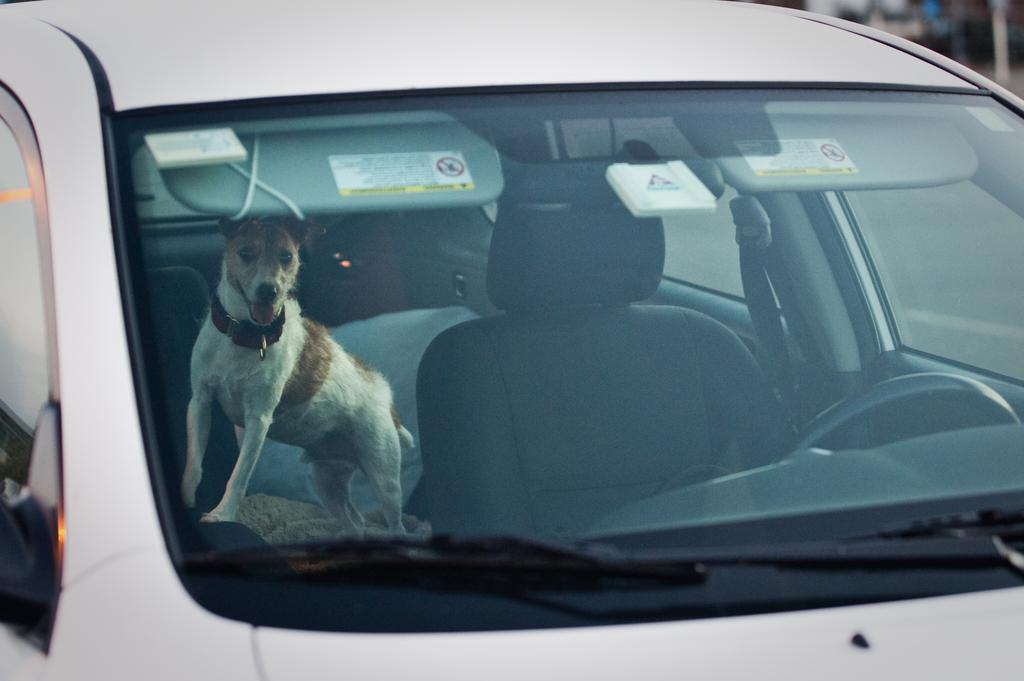What is the main subject of the image? The main subject of the image is a car. Is there anything else in the car besides the car itself? Yes, there is a dog in the car. Where is the drawer located in the image? There is no drawer present in the image. What type of neck accessory is the dog wearing in the image? The dog is not wearing any neck accessory in the image. 